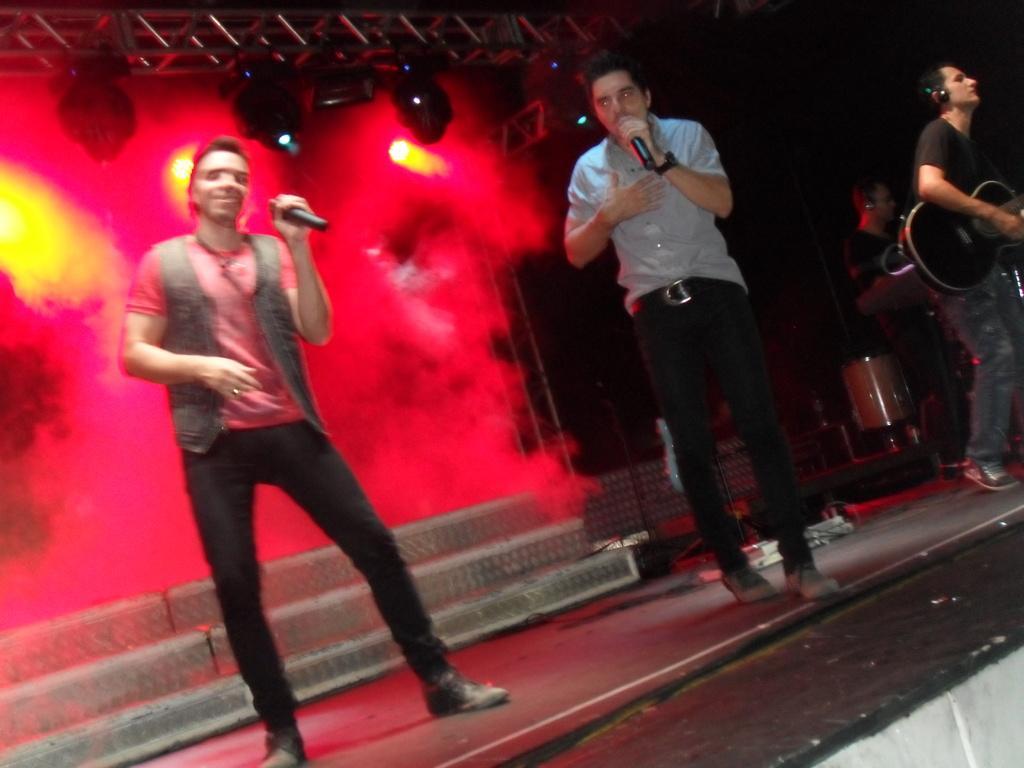Describe this image in one or two sentences. In this picture we can see people on the stage and two people are holding mics, here we can see musical instruments and in the background we can see lights and some objects. 